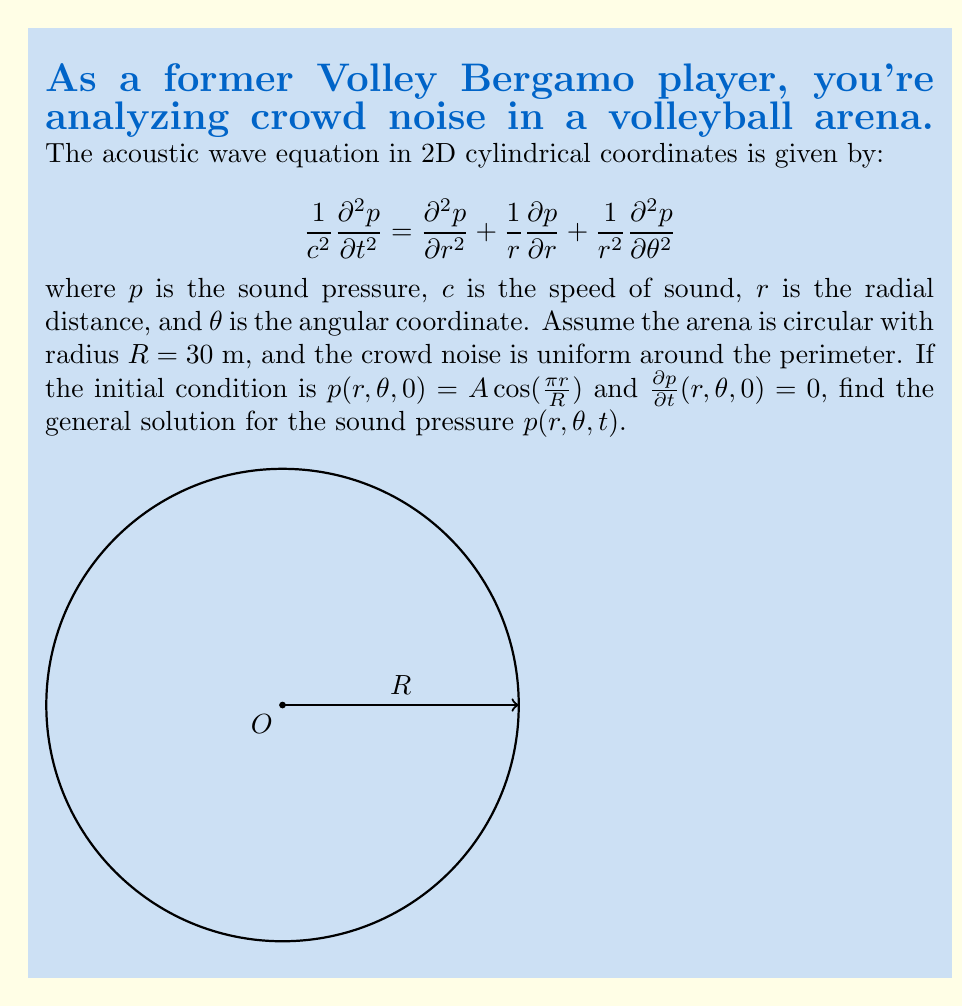Solve this math problem. To solve this problem, we'll follow these steps:

1) Given the uniform noise around the perimeter and the initial conditions, we can assume that the solution is independent of $\theta$. This simplifies our equation to:

   $$\frac{1}{c^2}\frac{\partial^2 p}{\partial t^2} = \frac{\partial^2 p}{\partial r^2} + \frac{1}{r}\frac{\partial p}{\partial r}$$

2) We can use the method of separation of variables. Let $p(r,t) = R(r)T(t)$. Substituting this into our equation:

   $$\frac{1}{c^2}\frac{T''(t)}{T(t)} = \frac{R''(r)}{R(r)} + \frac{1}{r}\frac{R'(r)}{R(r)} = -k^2$$

   where $k^2$ is a separation constant.

3) This gives us two equations:
   
   $$T''(t) + c^2k^2T(t) = 0$$
   $$r^2R''(r) + rR'(r) + k^2r^2R(r) = 0$$

4) The solution for $T(t)$ is:
   
   $$T(t) = A\cos(ckt) + B\sin(ckt)$$

5) The equation for $R(r)$ is Bessel's equation of order zero. Its solution is:
   
   $$R(r) = C J_0(kr) + D Y_0(kr)$$

   where $J_0$ and $Y_0$ are Bessel functions of the first and second kind, respectively.

6) Given the initial condition $p(r,\theta,0) = A\cos(\frac{\pi r}{R})$, we can deduce that $k = \frac{\pi}{R}$ and $D = 0$ (since $Y_0$ is singular at $r=0$).

7) The general solution is thus:

   $$p(r,t) = [A\cos(c\frac{\pi}{R}t) + B\sin(c\frac{\pi}{R}t)] J_0(\frac{\pi r}{R})$$

8) Using the initial condition $\frac{\partial p}{\partial t}(r,\theta,0) = 0$, we find that $B = 0$.

Therefore, the final solution is:

$$p(r,t) = A\cos(c\frac{\pi}{R}t) J_0(\frac{\pi r}{R})$$

where $A$ is determined by the initial amplitude of the sound pressure.
Answer: $p(r,t) = A\cos(c\frac{\pi}{R}t) J_0(\frac{\pi r}{R})$ 